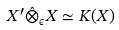<formula> <loc_0><loc_0><loc_500><loc_500>X ^ { \prime } \hat { \otimes } _ { \epsilon } X \simeq K ( X )</formula> 